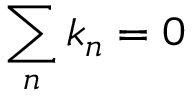<formula> <loc_0><loc_0><loc_500><loc_500>\sum _ { n } k _ { n } = 0</formula> 